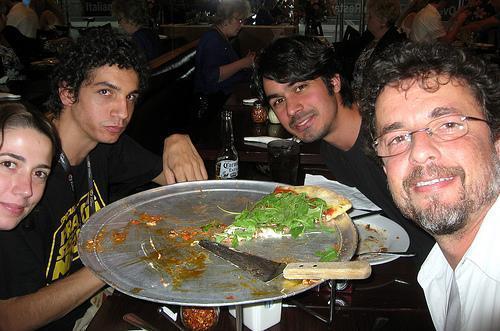How many people are looking at the camera?
Give a very brief answer. 4. How many pieces of pizza are left?
Give a very brief answer. 1. 